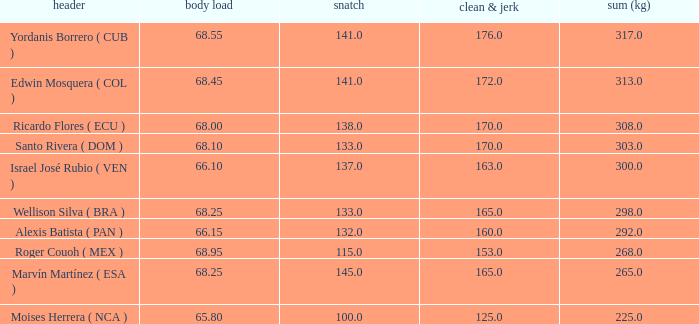Which Total (kg) has a Clean & Jerk smaller than 153, and a Snatch smaller than 100? None. 